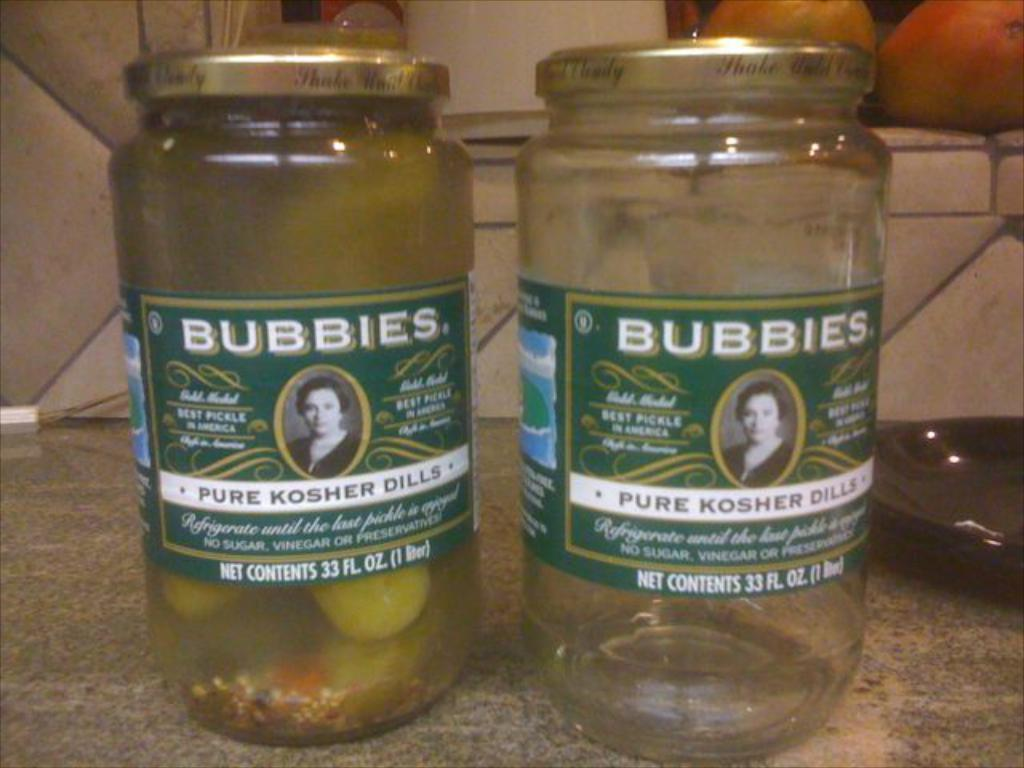How many glass bottles are visible in the image? There are two glass bottles in the image. What is the condition of the bottles? One of the bottles is empty, and there are items in the other bottle. What can be seen in the background of the image? There is a wall and fruits in the background of the image. What type of flame can be seen coming from the squirrel in the image? There is no squirrel or flame present in the image. What is the location of the image in relation to downtown? The location of the image in relation to downtown cannot be determined from the provided facts. 